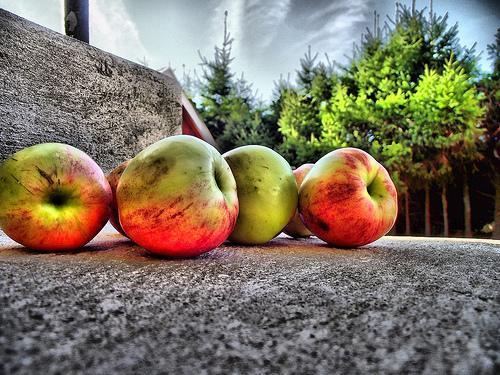How many apples are pictured?
Give a very brief answer. 6. How many apples are there?
Give a very brief answer. 6. 